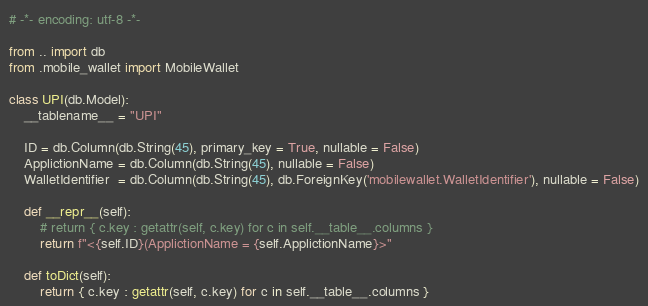<code> <loc_0><loc_0><loc_500><loc_500><_Python_># -*- encoding: utf-8 -*-

from .. import db
from .mobile_wallet import MobileWallet

class UPI(db.Model):
    __tablename__ = "UPI"

    ID = db.Column(db.String(45), primary_key = True, nullable = False)  
    ApplictionName = db.Column(db.String(45), nullable = False) 
    WalletIdentifier  = db.Column(db.String(45), db.ForeignKey('mobilewallet.WalletIdentifier'), nullable = False)

    def __repr__(self):
        # return { c.key : getattr(self, c.key) for c in self.__table__.columns }
        return f"<{self.ID}(ApplictionName = {self.ApplictionName}>"

    def toDict(self):
        return { c.key : getattr(self, c.key) for c in self.__table__.columns }</code> 